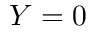<formula> <loc_0><loc_0><loc_500><loc_500>Y = 0</formula> 